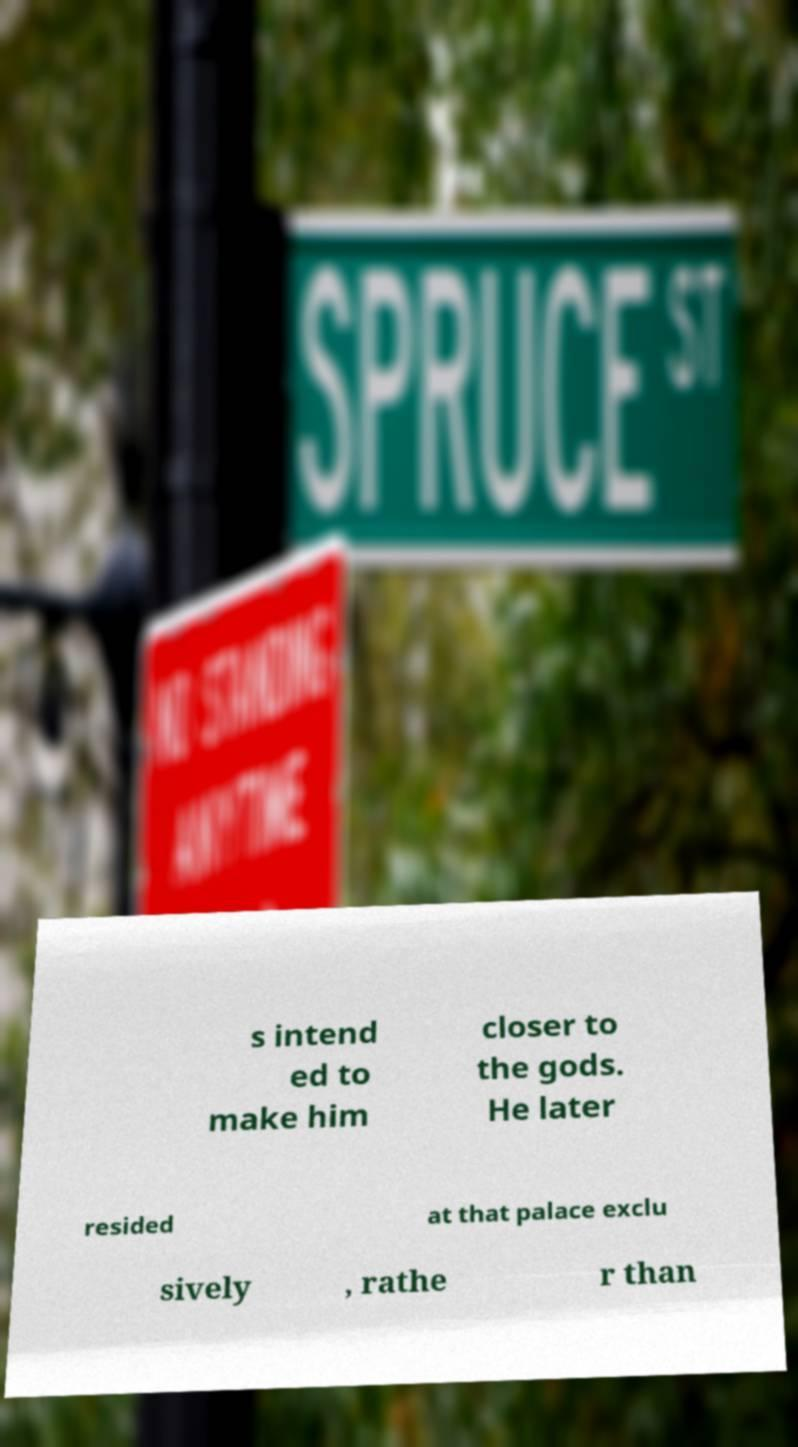I need the written content from this picture converted into text. Can you do that? s intend ed to make him closer to the gods. He later resided at that palace exclu sively , rathe r than 